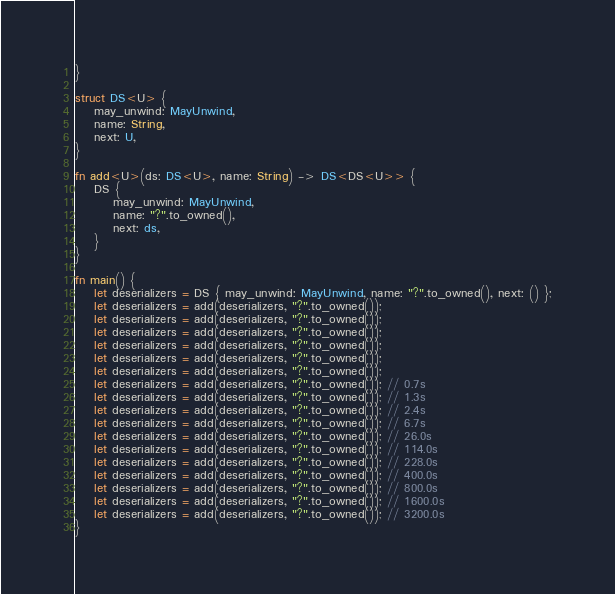Convert code to text. <code><loc_0><loc_0><loc_500><loc_500><_Rust_>}

struct DS<U> {
    may_unwind: MayUnwind,
    name: String,
    next: U,
}

fn add<U>(ds: DS<U>, name: String) -> DS<DS<U>> {
    DS {
        may_unwind: MayUnwind,
        name: "?".to_owned(),
        next: ds,
    }
}

fn main() {
    let deserializers = DS { may_unwind: MayUnwind, name: "?".to_owned(), next: () };
    let deserializers = add(deserializers, "?".to_owned());
    let deserializers = add(deserializers, "?".to_owned());
    let deserializers = add(deserializers, "?".to_owned());
    let deserializers = add(deserializers, "?".to_owned());
    let deserializers = add(deserializers, "?".to_owned());
    let deserializers = add(deserializers, "?".to_owned());
    let deserializers = add(deserializers, "?".to_owned()); // 0.7s
    let deserializers = add(deserializers, "?".to_owned()); // 1.3s
    let deserializers = add(deserializers, "?".to_owned()); // 2.4s
    let deserializers = add(deserializers, "?".to_owned()); // 6.7s
    let deserializers = add(deserializers, "?".to_owned()); // 26.0s
    let deserializers = add(deserializers, "?".to_owned()); // 114.0s
    let deserializers = add(deserializers, "?".to_owned()); // 228.0s
    let deserializers = add(deserializers, "?".to_owned()); // 400.0s
    let deserializers = add(deserializers, "?".to_owned()); // 800.0s
    let deserializers = add(deserializers, "?".to_owned()); // 1600.0s
    let deserializers = add(deserializers, "?".to_owned()); // 3200.0s
}
</code> 